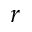<formula> <loc_0><loc_0><loc_500><loc_500>r</formula> 